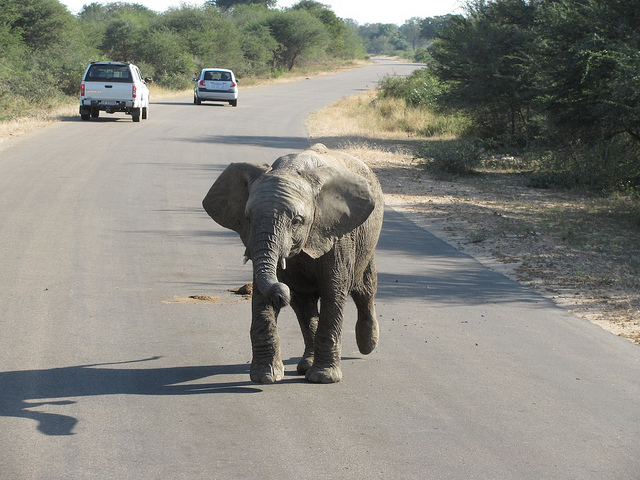Is the elephant going for a walk?
Answer the question using a single word or phrase. Yes How many cars are there? 2 Would ivory poachers be very tempted to hunt this elephant? No 